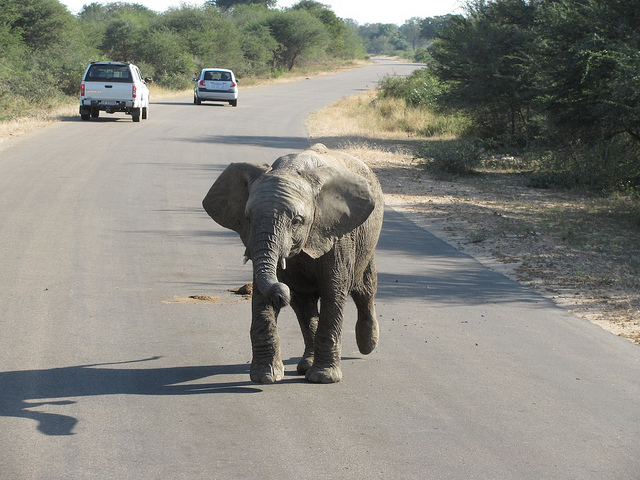Is the elephant going for a walk?
Answer the question using a single word or phrase. Yes How many cars are there? 2 Would ivory poachers be very tempted to hunt this elephant? No 